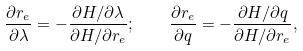<formula> <loc_0><loc_0><loc_500><loc_500>\frac { \partial r _ { e } } { \partial \lambda } = - \frac { \partial H / \partial \lambda } { \partial H / \partial r _ { e } } ; \quad \frac { \partial r _ { e } } { \partial q } = - \frac { \partial H / \partial q } { \partial H / \partial r _ { e } } ,</formula> 